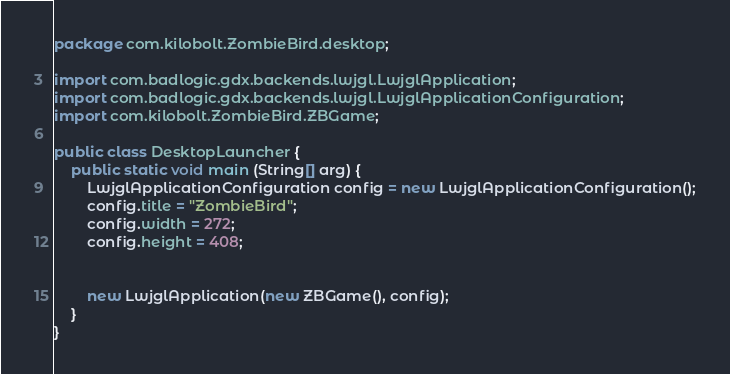<code> <loc_0><loc_0><loc_500><loc_500><_Java_>package com.kilobolt.ZombieBird.desktop;

import com.badlogic.gdx.backends.lwjgl.LwjglApplication;
import com.badlogic.gdx.backends.lwjgl.LwjglApplicationConfiguration;
import com.kilobolt.ZombieBird.ZBGame;

public class DesktopLauncher {
	public static void main (String[] arg) {
		LwjglApplicationConfiguration config = new LwjglApplicationConfiguration();
		config.title = "ZombieBird";
		config.width = 272;
		config.height = 408;
		
		
		new LwjglApplication(new ZBGame(), config);
	}
}
</code> 